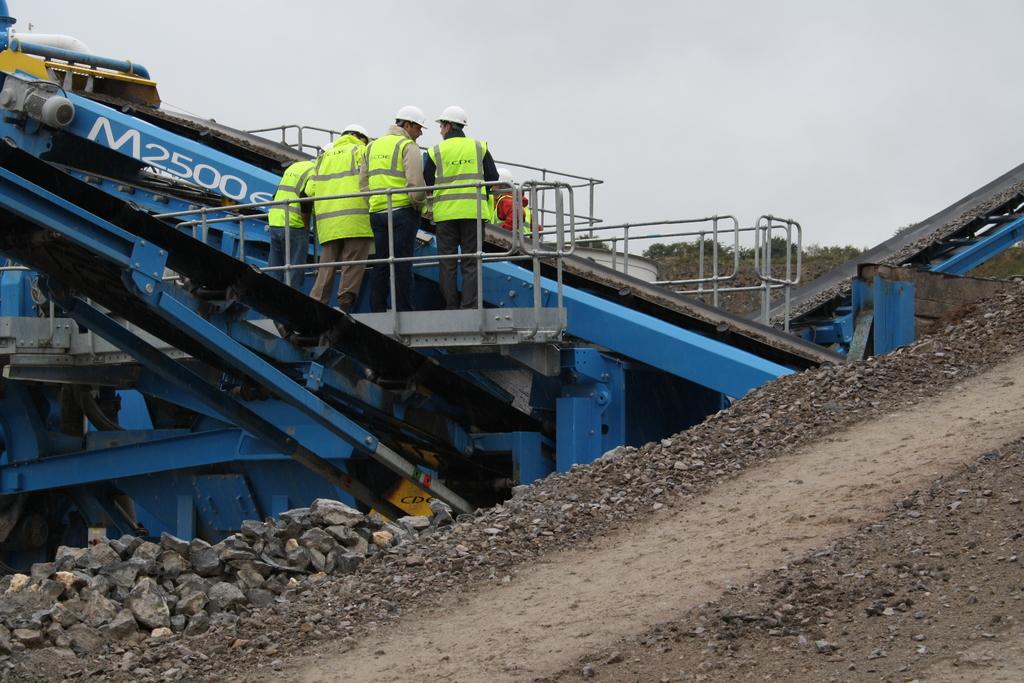What type of crane is that?
Your answer should be very brief. M2500. 